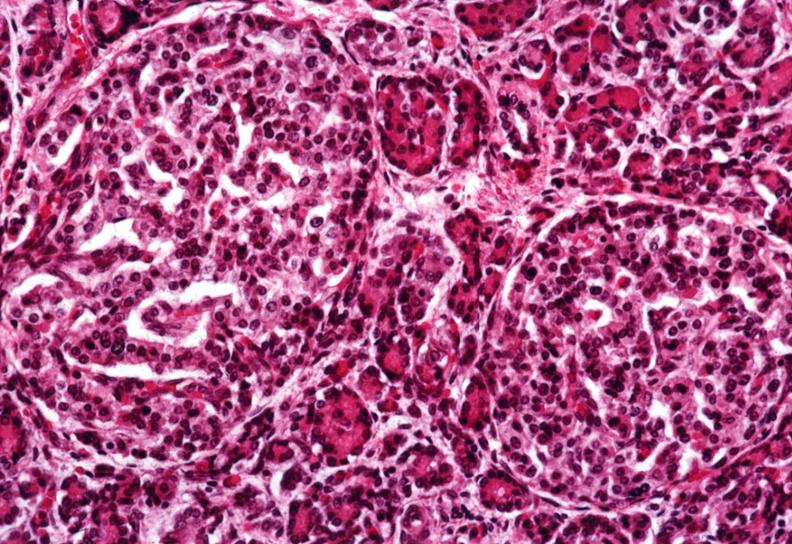s multiple and typical lesions present?
Answer the question using a single word or phrase. No 